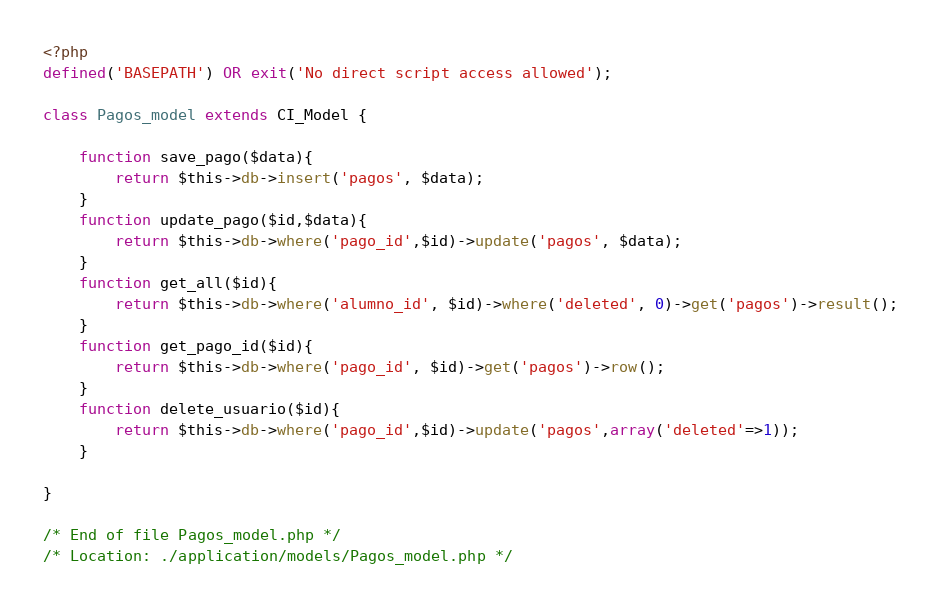Convert code to text. <code><loc_0><loc_0><loc_500><loc_500><_PHP_><?php
defined('BASEPATH') OR exit('No direct script access allowed');

class Pagos_model extends CI_Model {

	function save_pago($data){
		return $this->db->insert('pagos', $data);
	}
	function update_pago($id,$data){
		return $this->db->where('pago_id',$id)->update('pagos', $data);
	}
	function get_all($id){
		return $this->db->where('alumno_id', $id)->where('deleted', 0)->get('pagos')->result();
	}
	function get_pago_id($id){
		return $this->db->where('pago_id', $id)->get('pagos')->row();
	}
	function delete_usuario($id){
		return $this->db->where('pago_id',$id)->update('pagos',array('deleted'=>1));
	}

}

/* End of file Pagos_model.php */
/* Location: ./application/models/Pagos_model.php */</code> 